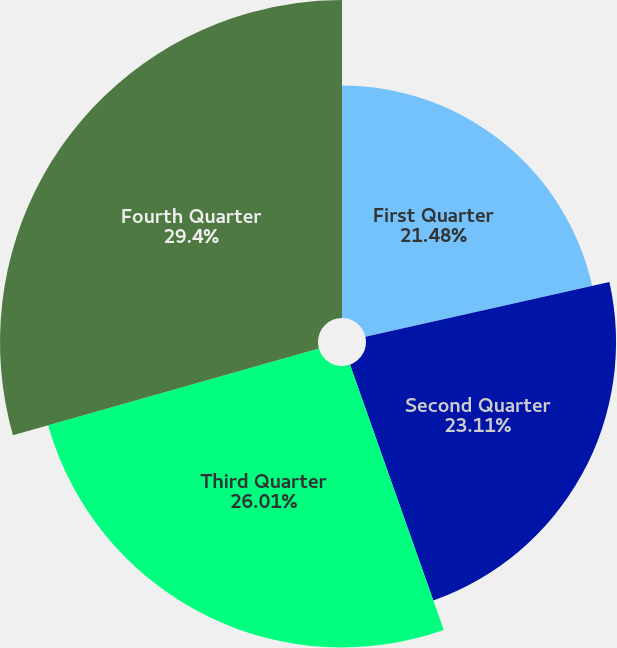Convert chart. <chart><loc_0><loc_0><loc_500><loc_500><pie_chart><fcel>First Quarter<fcel>Second Quarter<fcel>Third Quarter<fcel>Fourth Quarter<nl><fcel>21.48%<fcel>23.11%<fcel>26.01%<fcel>29.39%<nl></chart> 